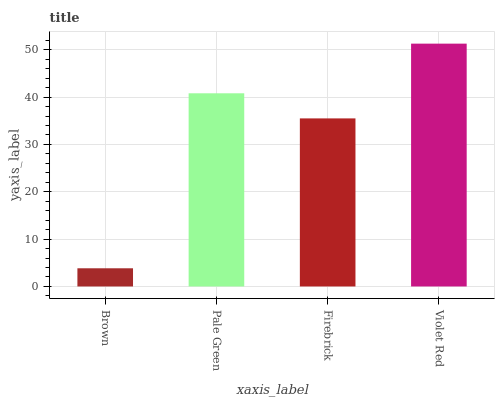Is Brown the minimum?
Answer yes or no. Yes. Is Violet Red the maximum?
Answer yes or no. Yes. Is Pale Green the minimum?
Answer yes or no. No. Is Pale Green the maximum?
Answer yes or no. No. Is Pale Green greater than Brown?
Answer yes or no. Yes. Is Brown less than Pale Green?
Answer yes or no. Yes. Is Brown greater than Pale Green?
Answer yes or no. No. Is Pale Green less than Brown?
Answer yes or no. No. Is Pale Green the high median?
Answer yes or no. Yes. Is Firebrick the low median?
Answer yes or no. Yes. Is Brown the high median?
Answer yes or no. No. Is Brown the low median?
Answer yes or no. No. 